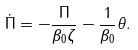<formula> <loc_0><loc_0><loc_500><loc_500>\dot { \Pi } = - \frac { \Pi } { \beta _ { 0 } \zeta } - \frac { 1 } { \beta _ { 0 } } \theta .</formula> 